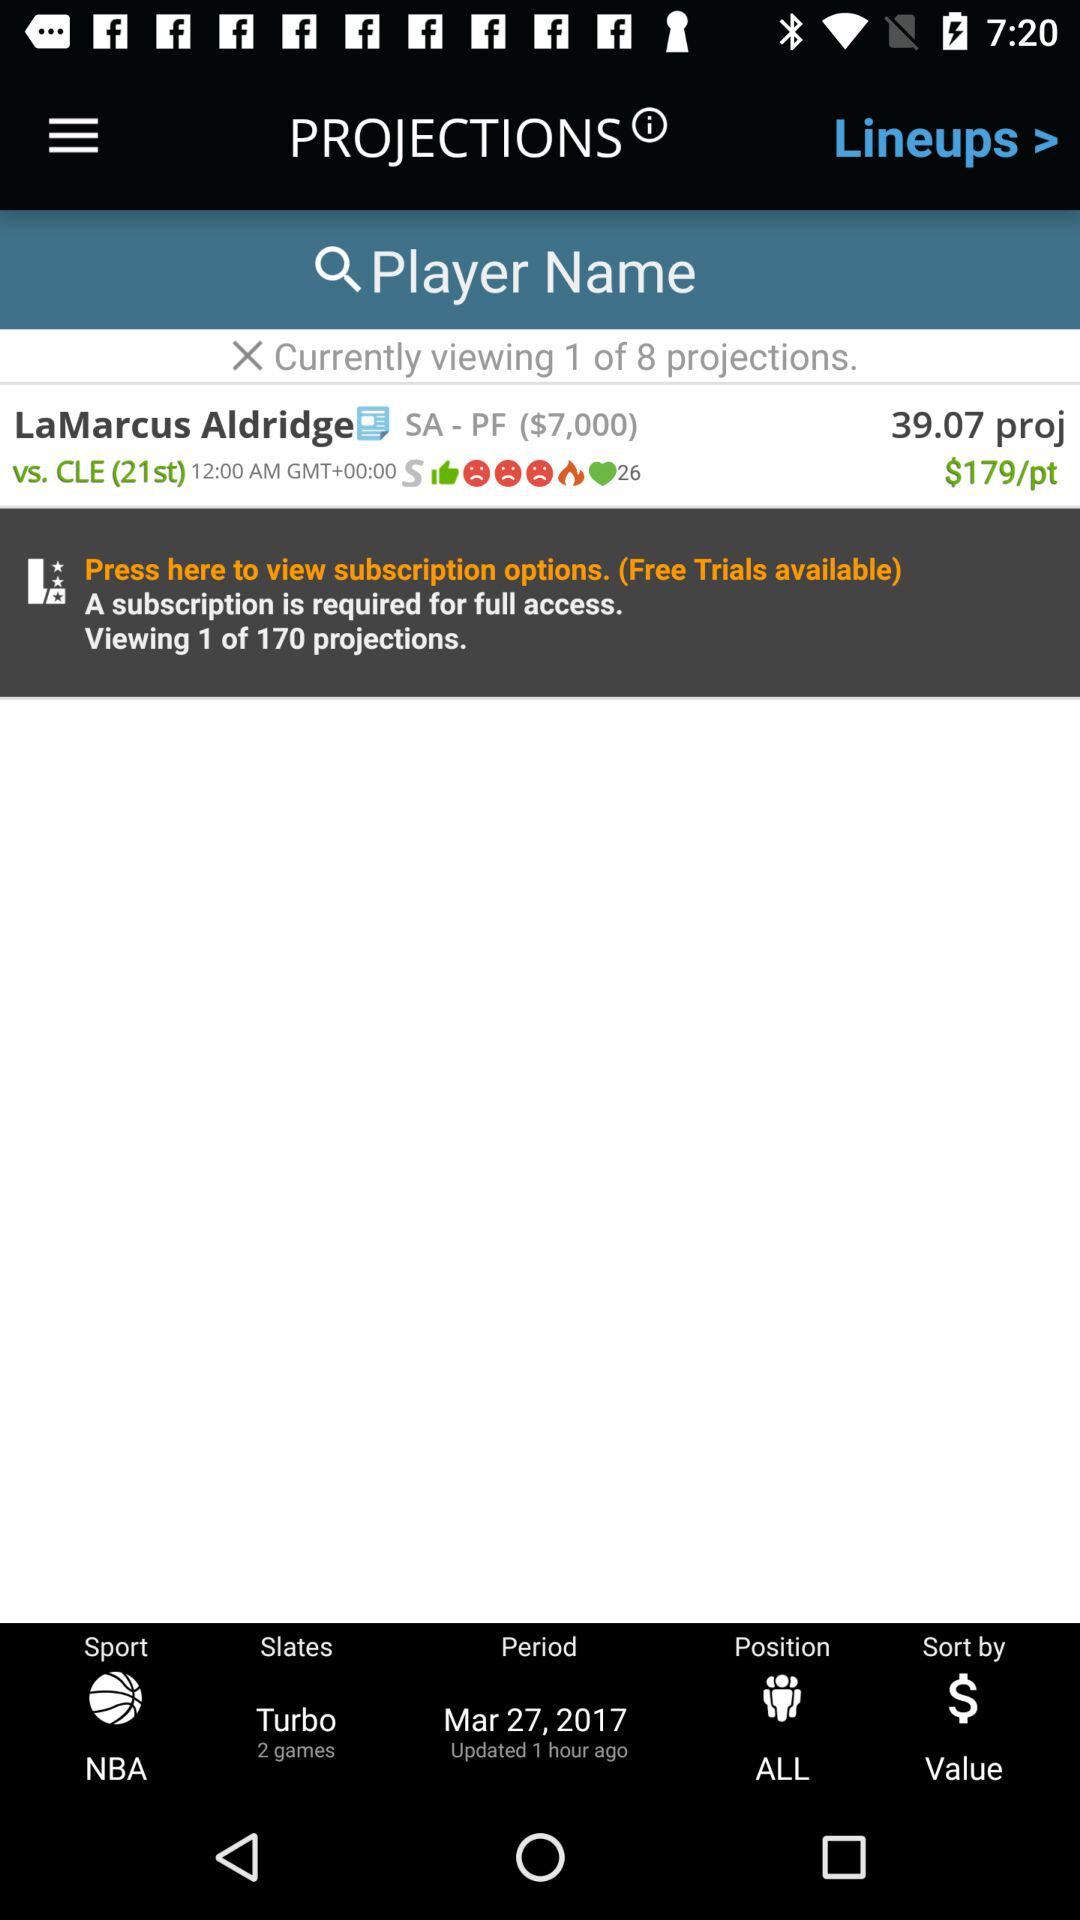How many more projections are available than the current one?
Answer the question using a single word or phrase. 169 